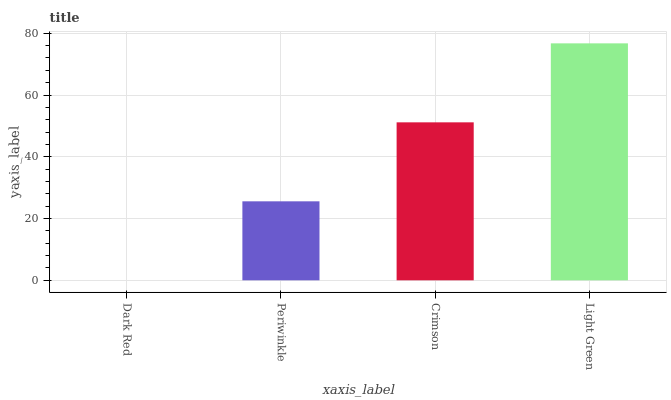Is Dark Red the minimum?
Answer yes or no. Yes. Is Light Green the maximum?
Answer yes or no. Yes. Is Periwinkle the minimum?
Answer yes or no. No. Is Periwinkle the maximum?
Answer yes or no. No. Is Periwinkle greater than Dark Red?
Answer yes or no. Yes. Is Dark Red less than Periwinkle?
Answer yes or no. Yes. Is Dark Red greater than Periwinkle?
Answer yes or no. No. Is Periwinkle less than Dark Red?
Answer yes or no. No. Is Crimson the high median?
Answer yes or no. Yes. Is Periwinkle the low median?
Answer yes or no. Yes. Is Light Green the high median?
Answer yes or no. No. Is Light Green the low median?
Answer yes or no. No. 